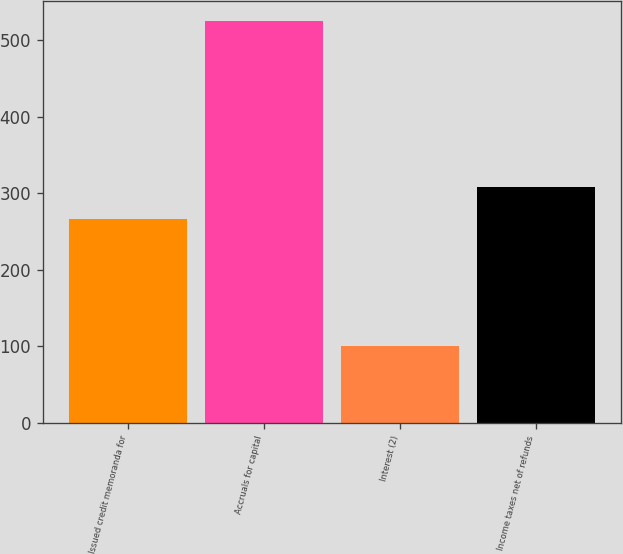<chart> <loc_0><loc_0><loc_500><loc_500><bar_chart><fcel>Issued credit memoranda for<fcel>Accruals for capital<fcel>Interest (2)<fcel>Income taxes net of refunds<nl><fcel>266<fcel>525<fcel>100<fcel>308.5<nl></chart> 